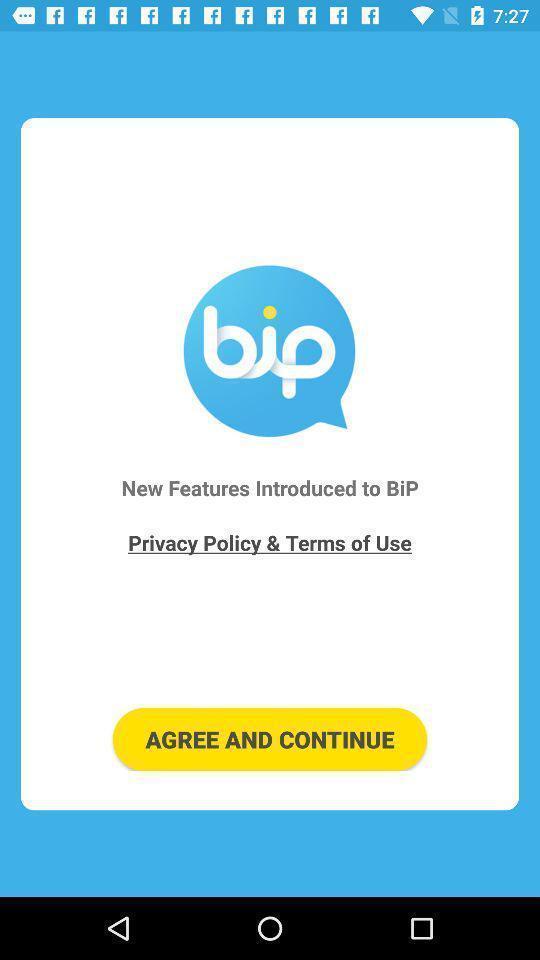Describe the visual elements of this screenshot. Welcome page for a messenger app. 